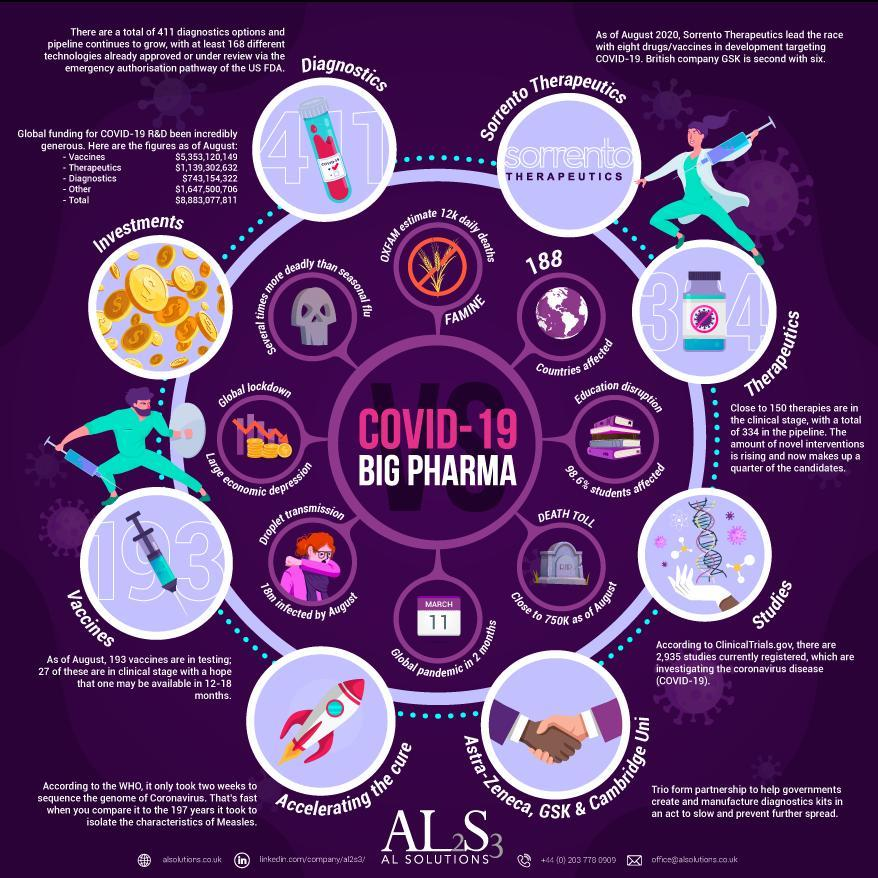How much is the global funding for COVID-19 R&D in diagnostics as of August 2020?
Answer the question with a short phrase. $743,154,322 When was coronavirus declared as a global pandemic? MARCH 11 What is the total global funding for COVID-19 R&D as of August 2020? $8,883,077,811 How many people per day could die from Covid-related hunger as per the OXFAM estimate? 12k How many countries were affected by COVID-19 as of August 2020? 188 What is the death toll due to Covid-19 as of August 2020? Close to 750k How many people were affected by COVID-19 through droplet transmission by August 2020? 18m What percentage of students education is affected by the impact of Covid-19 as of August 2020? 98.6% 